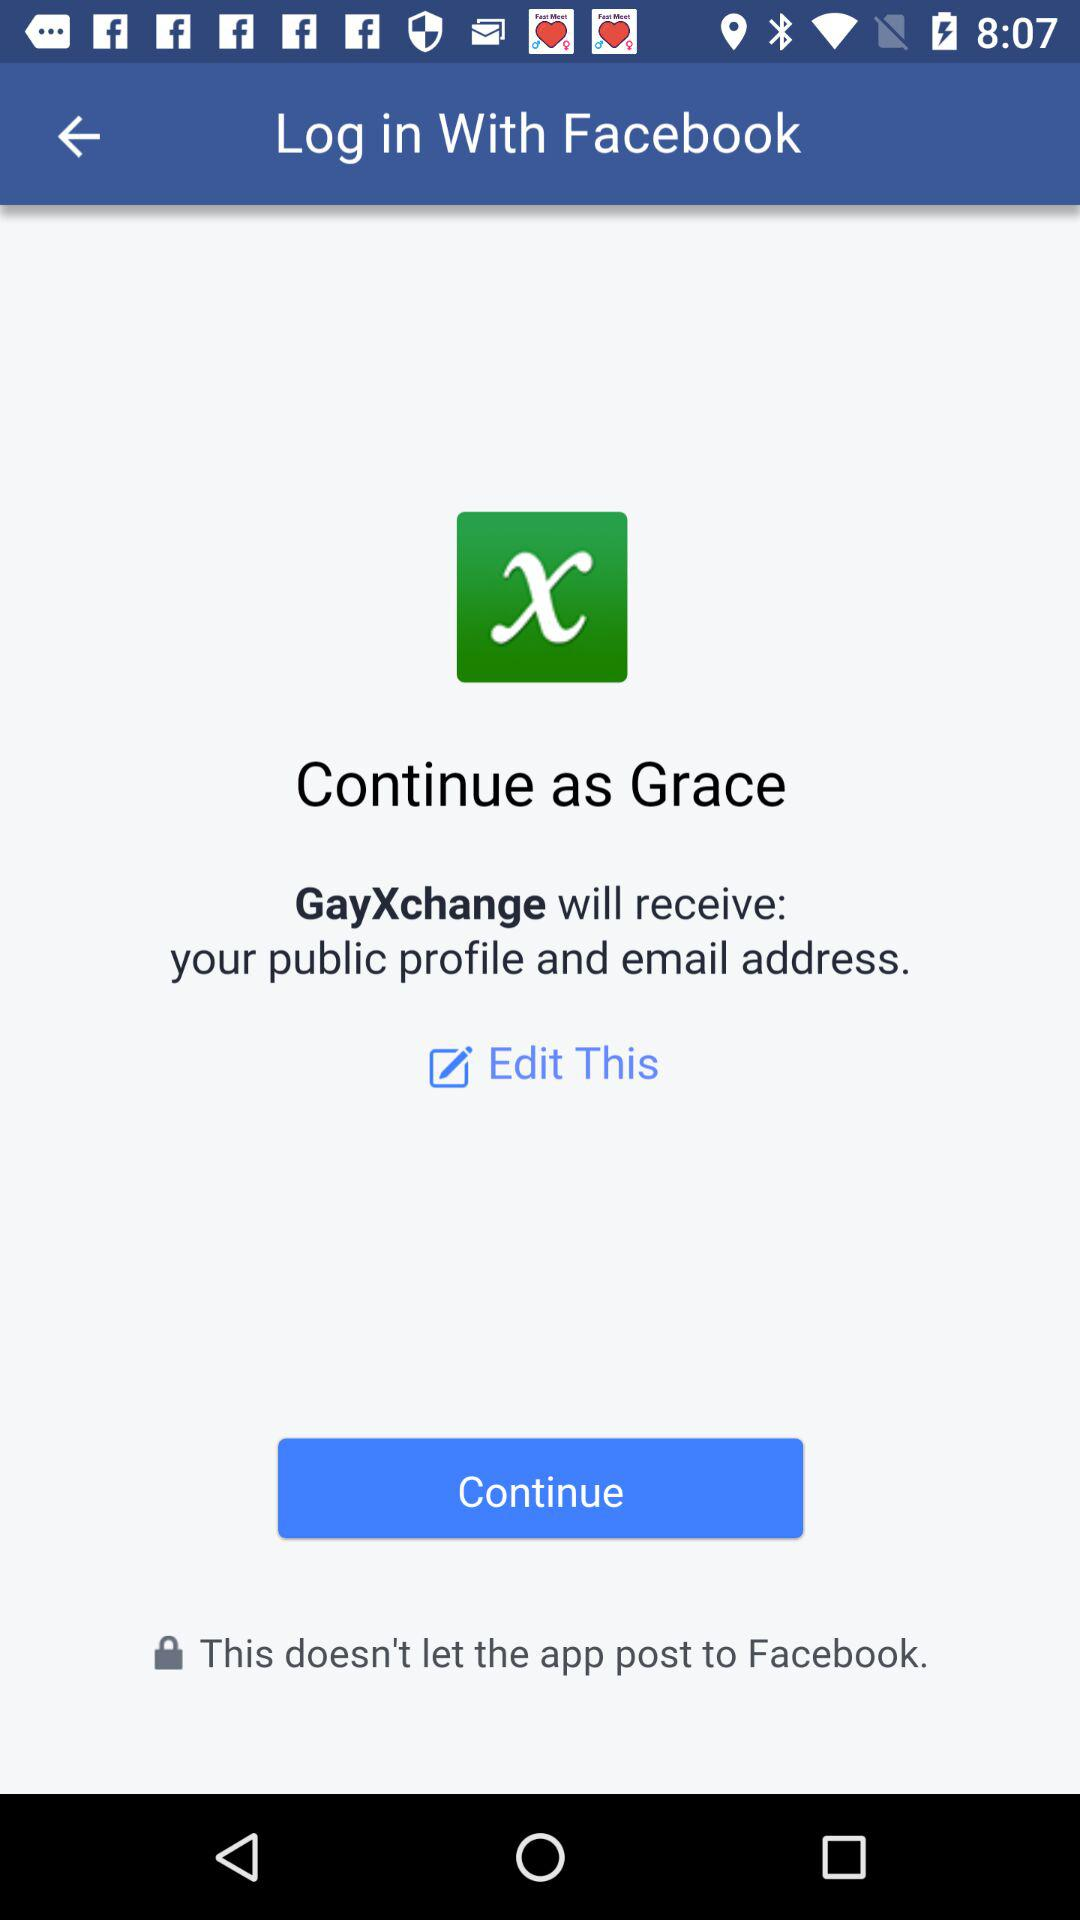What application is asking for permission? The application asking for permission is "GayXchange". 